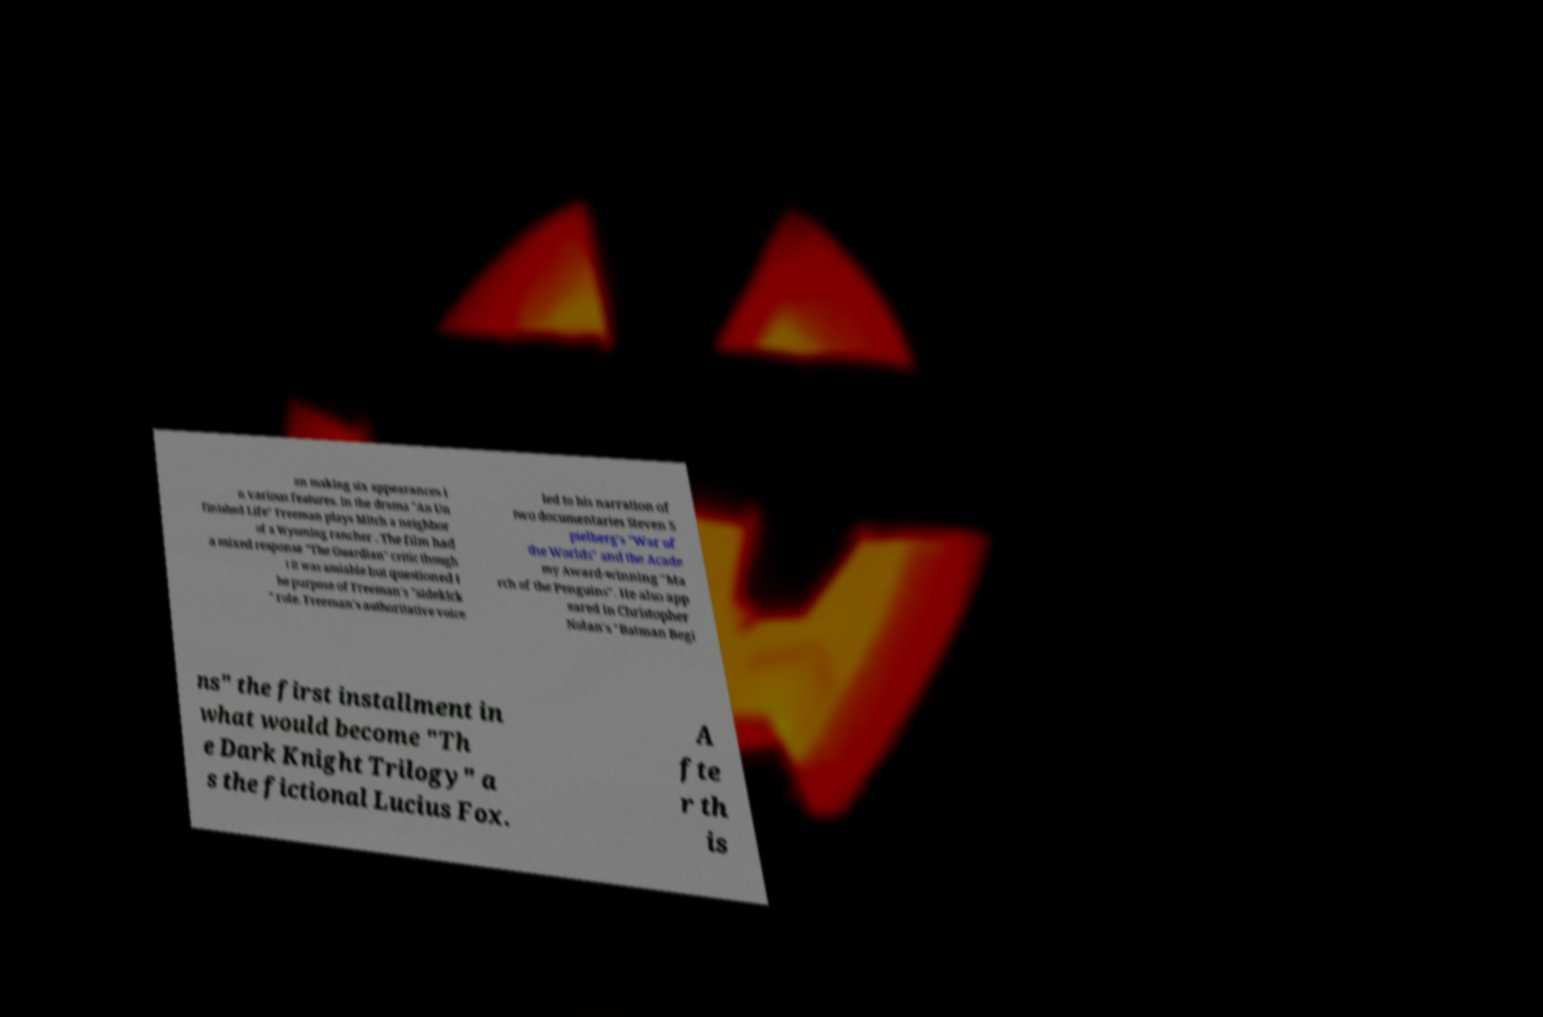Can you accurately transcribe the text from the provided image for me? an making six appearances i n various features. In the drama "An Un finished Life" Freeman plays Mitch a neighbor of a Wyoming rancher . The film had a mixed response "The Guardian" critic though t it was amiable but questioned t he purpose of Freeman's "sidekick " role. Freeman's authoritative voice led to his narration of two documentaries Steven S pielberg's "War of the Worlds" and the Acade my Award-winning "Ma rch of the Penguins". He also app eared in Christopher Nolan's "Batman Begi ns" the first installment in what would become "Th e Dark Knight Trilogy" a s the fictional Lucius Fox. A fte r th is 